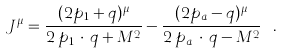Convert formula to latex. <formula><loc_0><loc_0><loc_500><loc_500>J ^ { \mu } = \frac { ( 2 p _ { 1 } + q ) ^ { \mu } } { 2 \, p _ { 1 } \, \cdot \, q + M ^ { 2 } } - \frac { ( 2 p _ { a } - q ) ^ { \mu } } { 2 \, p _ { a } \, \cdot \, q - M ^ { 2 } } \ .</formula> 